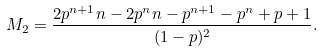Convert formula to latex. <formula><loc_0><loc_0><loc_500><loc_500>M _ { 2 } = \frac { 2 p ^ { n + 1 } n - 2 p ^ { n } n - p ^ { n + 1 } - p ^ { n } + p + 1 } { ( 1 - p ) ^ { 2 } } .</formula> 